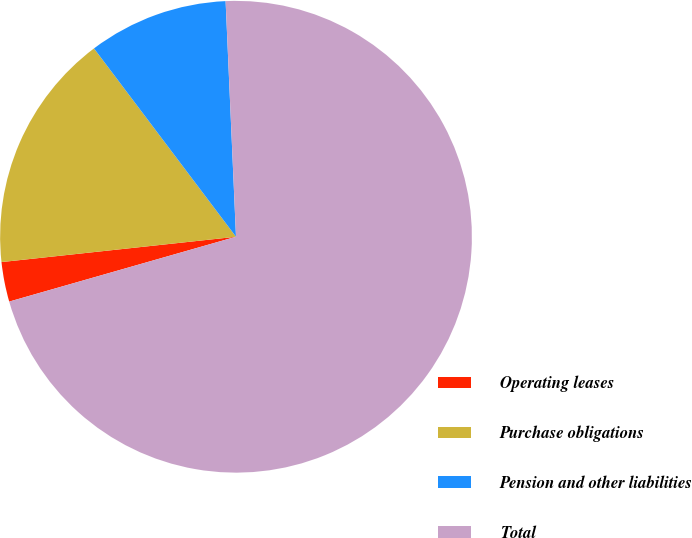Convert chart to OTSL. <chart><loc_0><loc_0><loc_500><loc_500><pie_chart><fcel>Operating leases<fcel>Purchase obligations<fcel>Pension and other liabilities<fcel>Total<nl><fcel>2.72%<fcel>16.43%<fcel>9.58%<fcel>71.27%<nl></chart> 